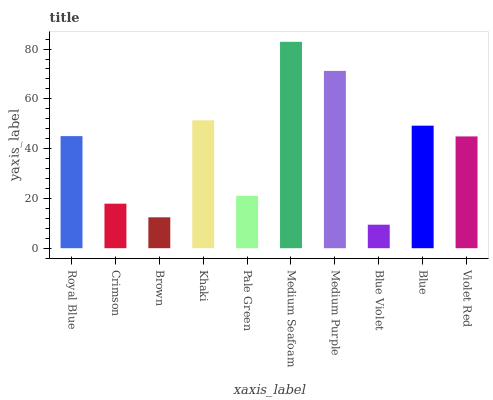Is Blue Violet the minimum?
Answer yes or no. Yes. Is Medium Seafoam the maximum?
Answer yes or no. Yes. Is Crimson the minimum?
Answer yes or no. No. Is Crimson the maximum?
Answer yes or no. No. Is Royal Blue greater than Crimson?
Answer yes or no. Yes. Is Crimson less than Royal Blue?
Answer yes or no. Yes. Is Crimson greater than Royal Blue?
Answer yes or no. No. Is Royal Blue less than Crimson?
Answer yes or no. No. Is Royal Blue the high median?
Answer yes or no. Yes. Is Violet Red the low median?
Answer yes or no. Yes. Is Crimson the high median?
Answer yes or no. No. Is Medium Seafoam the low median?
Answer yes or no. No. 